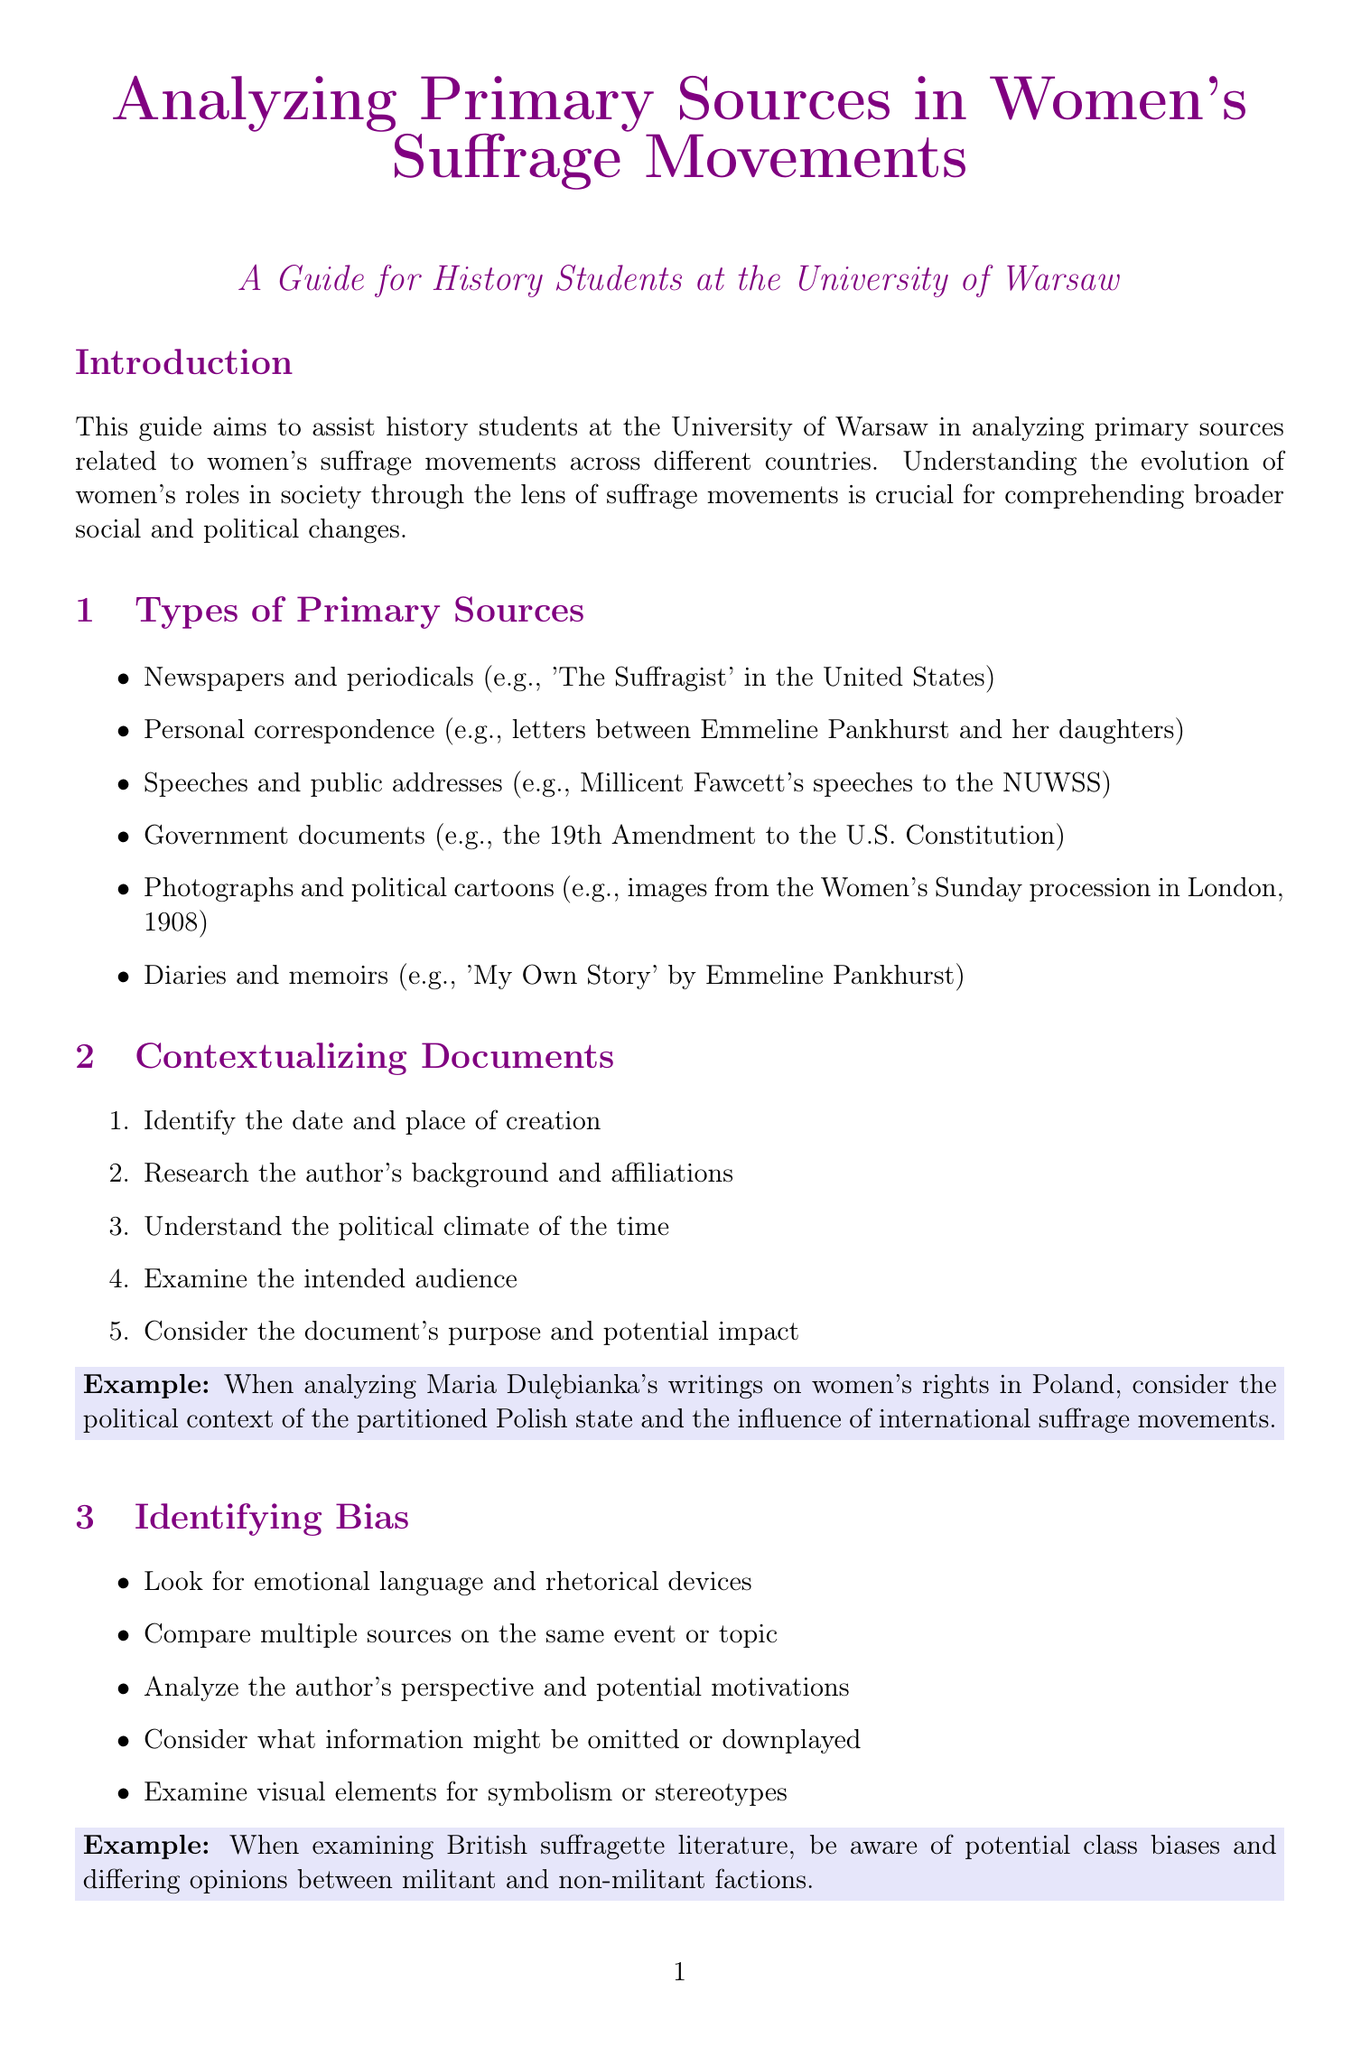What is the title of the guide? The title of the guide is provided in the document.
Answer: Analyzing Primary Sources in Women's Suffrage Movements: A Guide for History Students Who founded the Women's Social and Political Union? The document lists key figures and organizations, detailing founders.
Answer: Emmeline Pankhurst In what year did women in Poland gain the right to vote? The timeline section lists key events along with their corresponding years.
Answer: 1919 What type of resource is the Central Archives of Modern Records? The document describes different research resources available.
Answer: Archives Which organization is described as advocating for women's suffrage through peaceful means? The document provides descriptions of different organizations and their approaches.
Answer: National Union of Women's Suffrage Societies (NUWSS) What is the purpose of the guide? The introduction section outlines the guide's main goal.
Answer: Assist history students at the University of Warsaw How many steps are there in the section on contextualizing documents? The document specifies techniques or steps in different sections, including contextualizing documents.
Answer: Five What year marks New Zealand's grant of voting rights to women? This information can be found in the timeline of key events.
Answer: 1893 